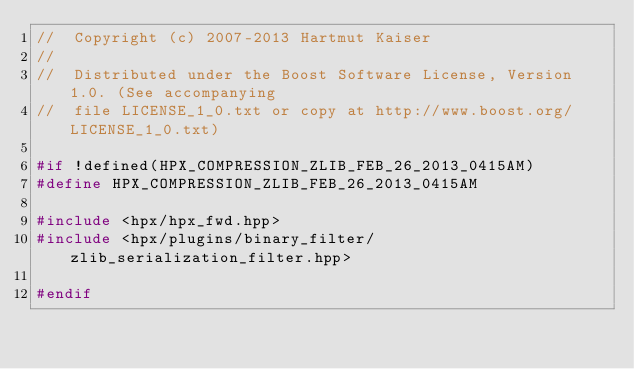Convert code to text. <code><loc_0><loc_0><loc_500><loc_500><_C++_>//  Copyright (c) 2007-2013 Hartmut Kaiser
//
//  Distributed under the Boost Software License, Version 1.0. (See accompanying
//  file LICENSE_1_0.txt or copy at http://www.boost.org/LICENSE_1_0.txt)

#if !defined(HPX_COMPRESSION_ZLIB_FEB_26_2013_0415AM)
#define HPX_COMPRESSION_ZLIB_FEB_26_2013_0415AM

#include <hpx/hpx_fwd.hpp>
#include <hpx/plugins/binary_filter/zlib_serialization_filter.hpp>

#endif

</code> 